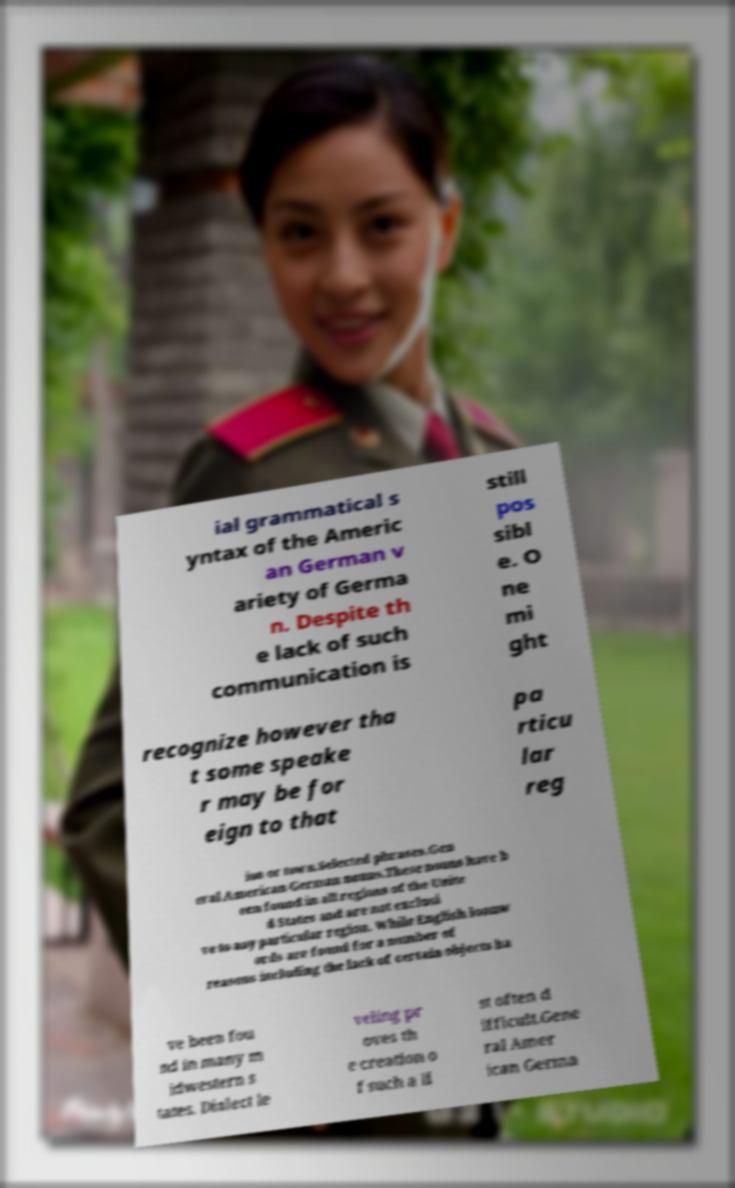What messages or text are displayed in this image? I need them in a readable, typed format. ial grammatical s yntax of the Americ an German v ariety of Germa n. Despite th e lack of such communication is still pos sibl e. O ne mi ght recognize however tha t some speake r may be for eign to that pa rticu lar reg ion or town.Selected phrases.Gen eral American German nouns.These nouns have b een found in all regions of the Unite d States and are not exclusi ve to any particular region. While English loanw ords are found for a number of reasons including the lack of certain objects ha ve been fou nd in many m idwestern s tates. Dialect le veling pr oves th e creation o f such a li st often d ifficult.Gene ral Amer ican Germa 